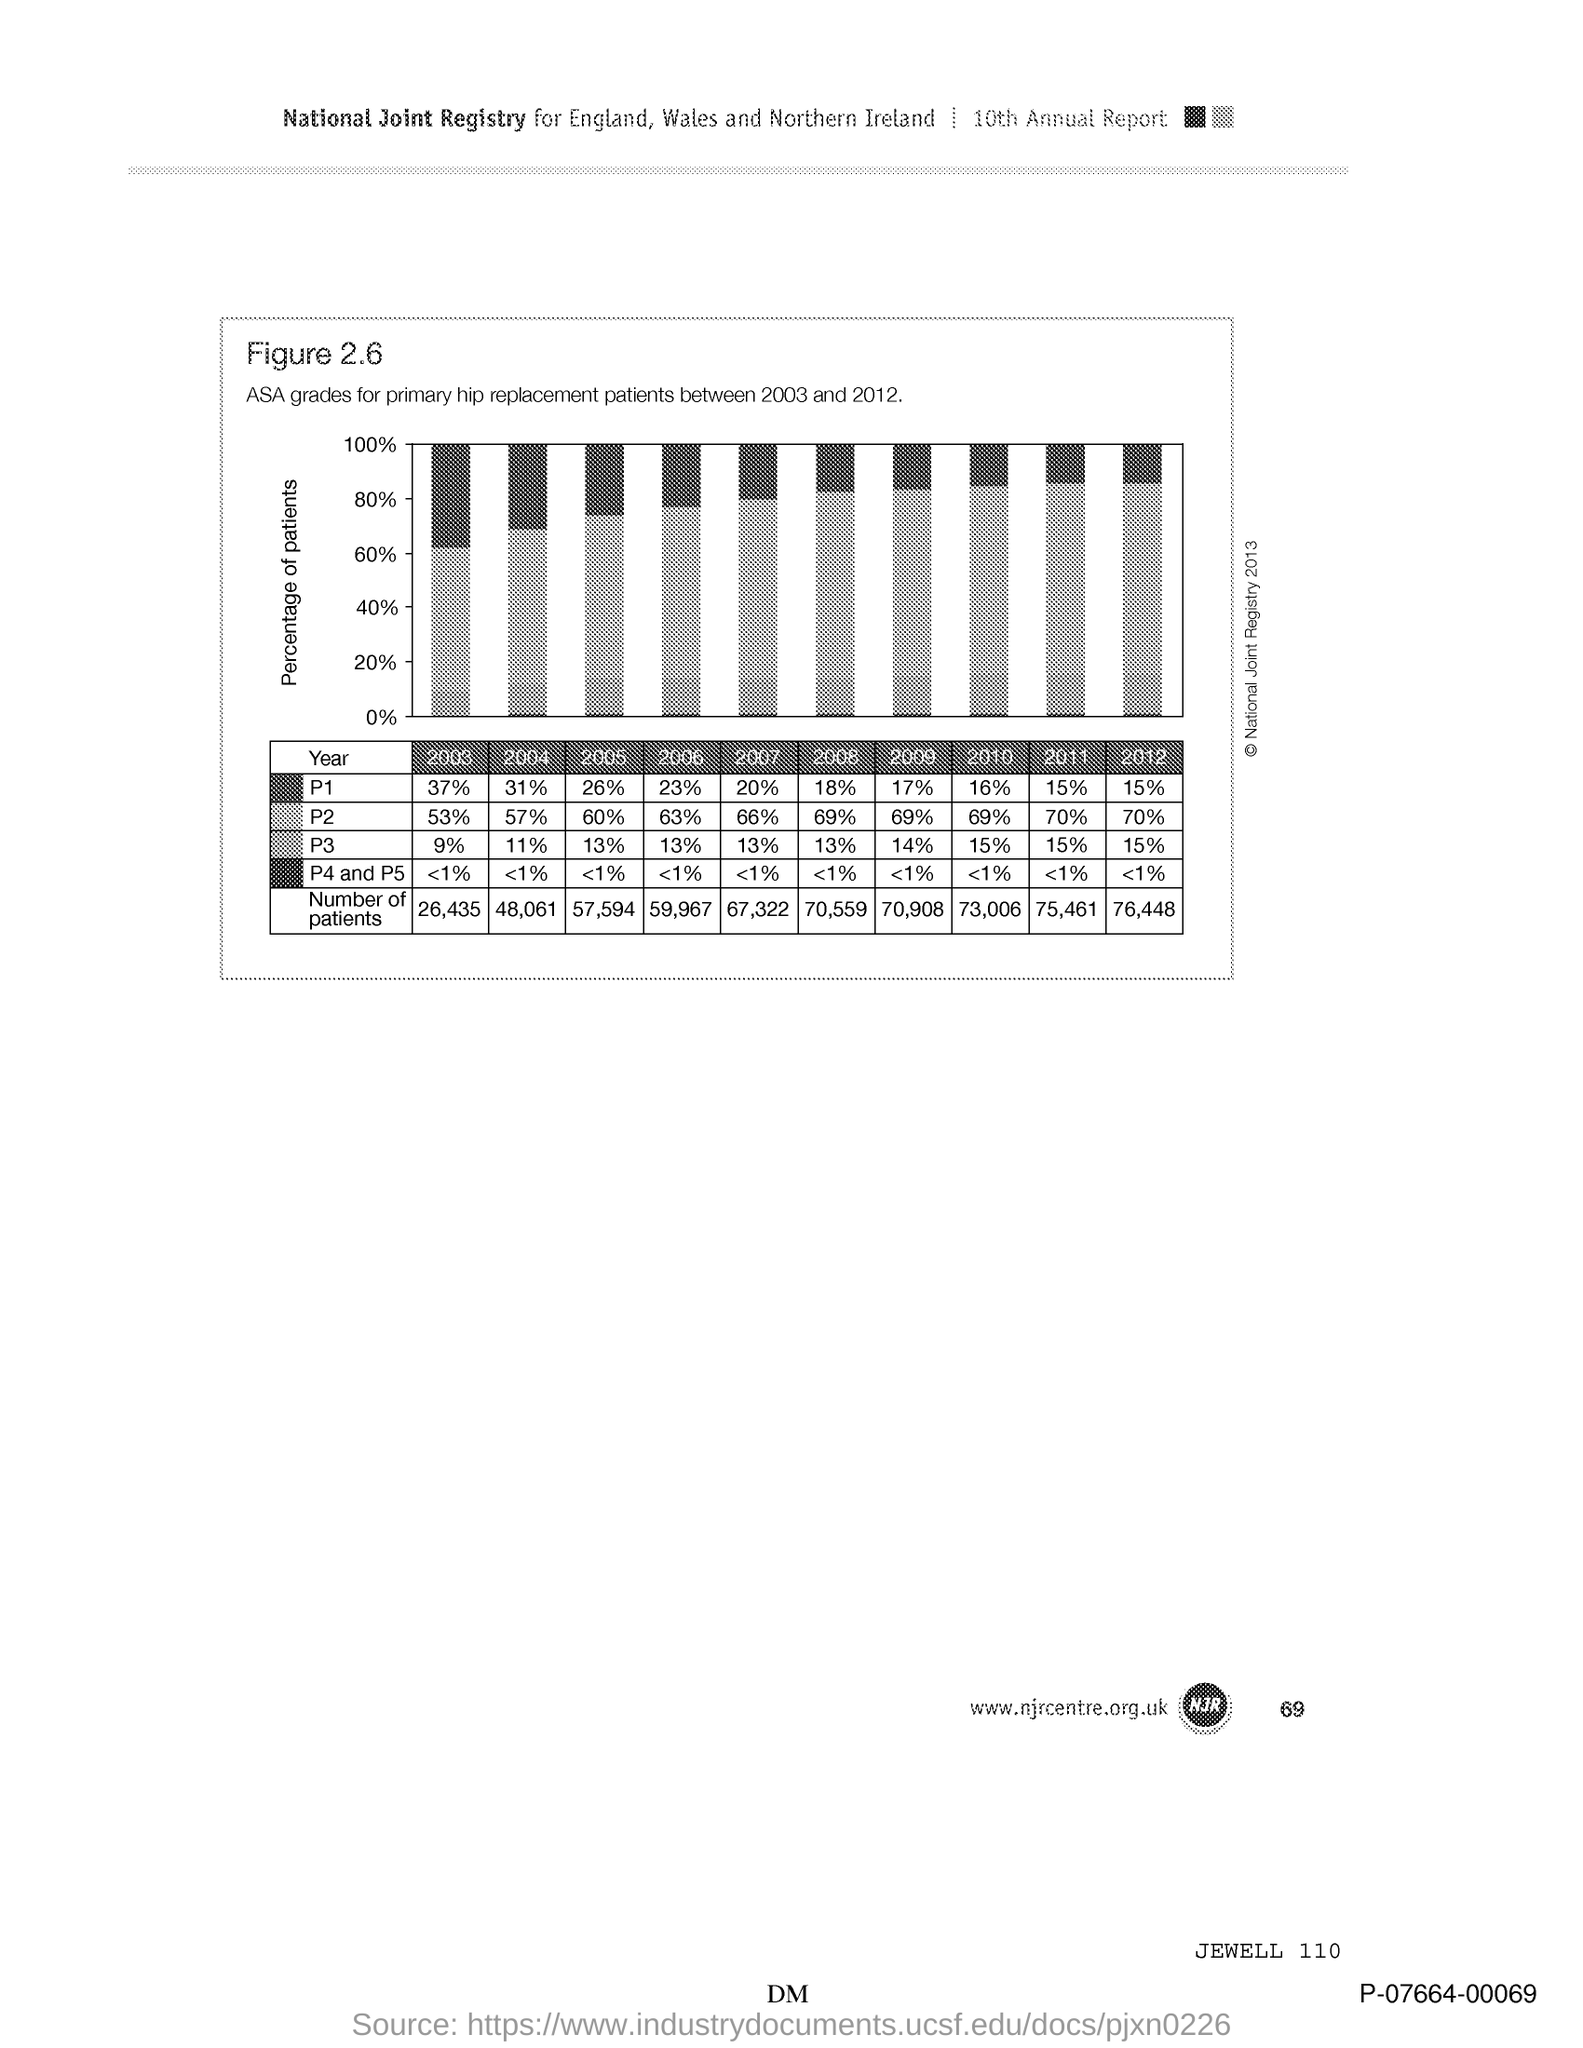What is Figure 2.6?
Keep it short and to the point. ASA grades for primary hip replacement patients between 2003 and 2012. What is the variable on Y axis of the graph?
Your response must be concise. Percentage of patients. 